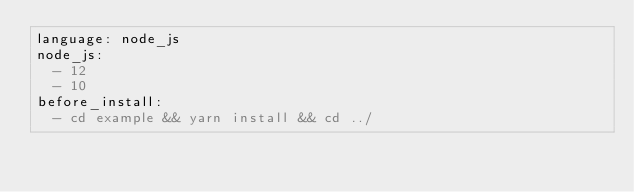<code> <loc_0><loc_0><loc_500><loc_500><_YAML_>language: node_js
node_js:
  - 12
  - 10
before_install:
  - cd example && yarn install && cd ../
</code> 